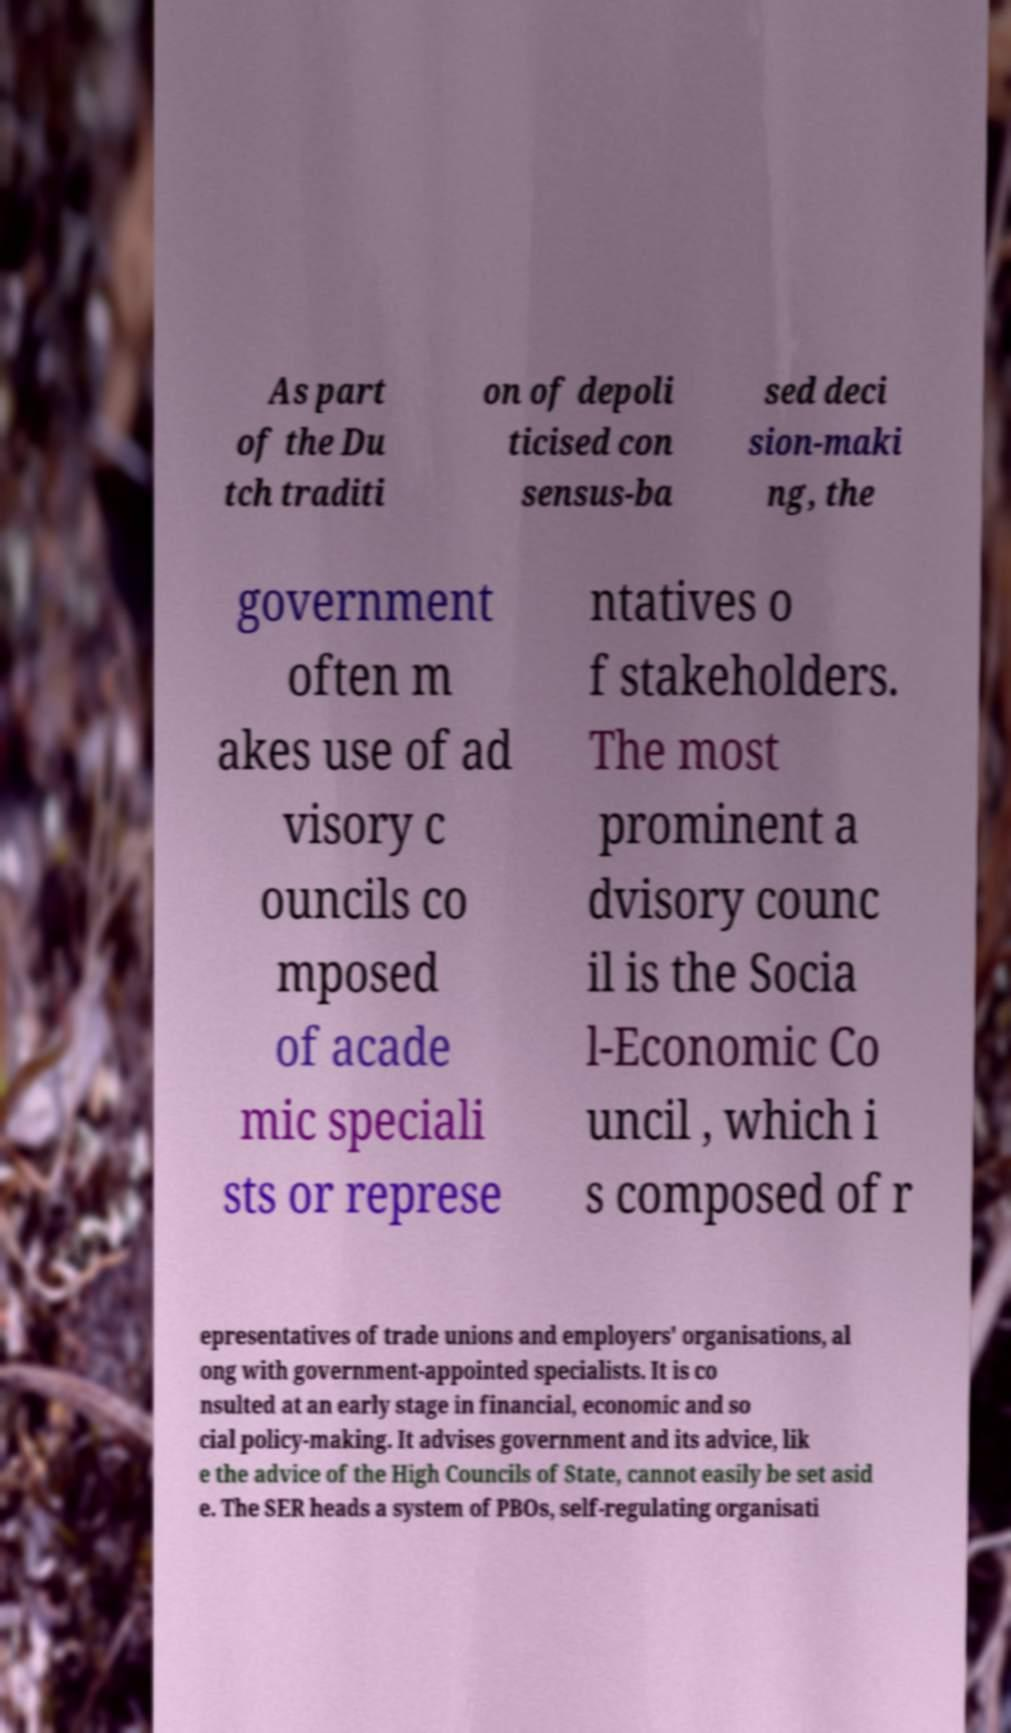Can you accurately transcribe the text from the provided image for me? As part of the Du tch traditi on of depoli ticised con sensus-ba sed deci sion-maki ng, the government often m akes use of ad visory c ouncils co mposed of acade mic speciali sts or represe ntatives o f stakeholders. The most prominent a dvisory counc il is the Socia l-Economic Co uncil , which i s composed of r epresentatives of trade unions and employers' organisations, al ong with government-appointed specialists. It is co nsulted at an early stage in financial, economic and so cial policy-making. It advises government and its advice, lik e the advice of the High Councils of State, cannot easily be set asid e. The SER heads a system of PBOs, self-regulating organisati 